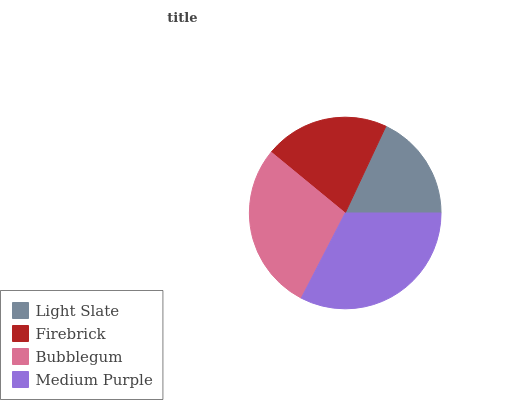Is Light Slate the minimum?
Answer yes or no. Yes. Is Medium Purple the maximum?
Answer yes or no. Yes. Is Firebrick the minimum?
Answer yes or no. No. Is Firebrick the maximum?
Answer yes or no. No. Is Firebrick greater than Light Slate?
Answer yes or no. Yes. Is Light Slate less than Firebrick?
Answer yes or no. Yes. Is Light Slate greater than Firebrick?
Answer yes or no. No. Is Firebrick less than Light Slate?
Answer yes or no. No. Is Bubblegum the high median?
Answer yes or no. Yes. Is Firebrick the low median?
Answer yes or no. Yes. Is Medium Purple the high median?
Answer yes or no. No. Is Light Slate the low median?
Answer yes or no. No. 